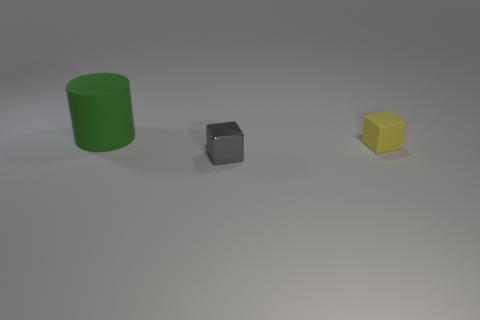Could you describe the shapes and colors of the objects in the image? Certainly! The image features three geometric objects: a large green cylinder, a smaller grey cube, and an even smaller yellow cube. Each object is rendered with a matte surface, diffusing the light and giving them a subdued appearance without any shiny reflections. 